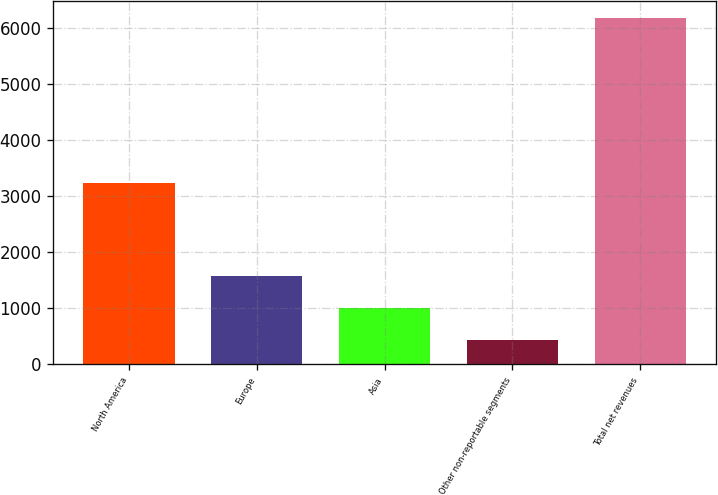<chart> <loc_0><loc_0><loc_500><loc_500><bar_chart><fcel>North America<fcel>Europe<fcel>Asia<fcel>Other non-reportable segments<fcel>Total net revenues<nl><fcel>3231<fcel>1585<fcel>1007.57<fcel>432.6<fcel>6182.3<nl></chart> 